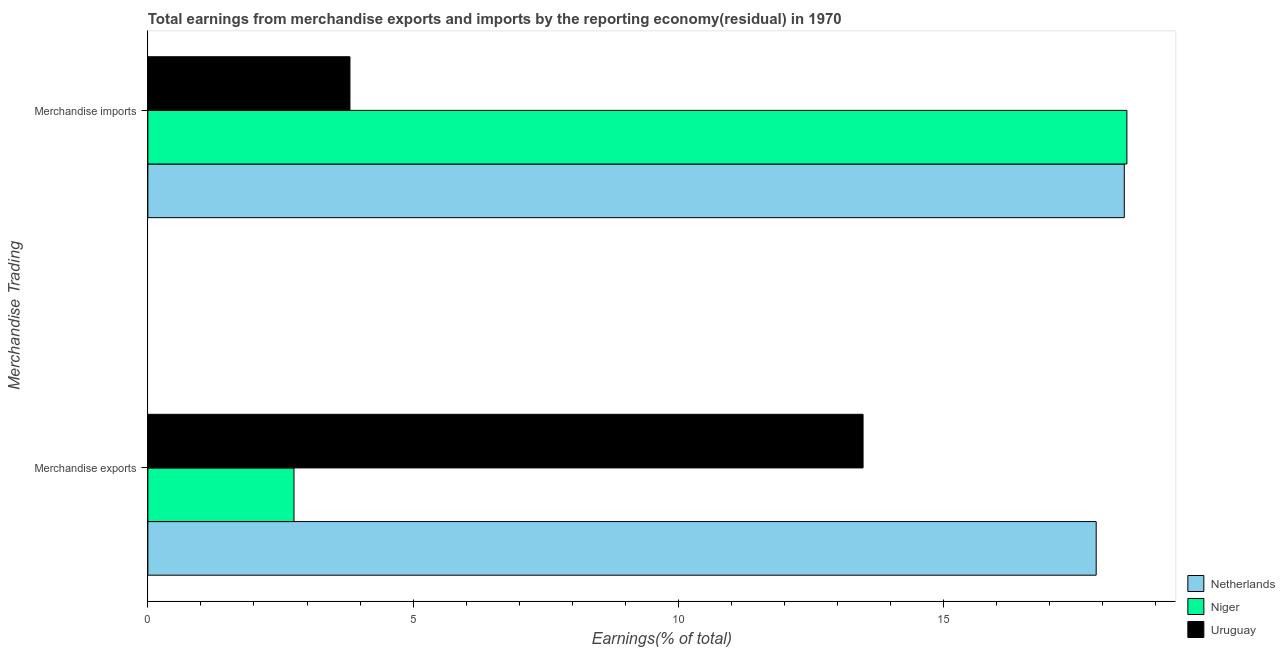Are the number of bars per tick equal to the number of legend labels?
Offer a terse response. Yes. How many bars are there on the 2nd tick from the top?
Your answer should be very brief. 3. How many bars are there on the 2nd tick from the bottom?
Give a very brief answer. 3. What is the earnings from merchandise imports in Uruguay?
Your answer should be very brief. 3.81. Across all countries, what is the maximum earnings from merchandise imports?
Give a very brief answer. 18.45. Across all countries, what is the minimum earnings from merchandise exports?
Make the answer very short. 2.75. In which country was the earnings from merchandise exports maximum?
Your answer should be compact. Netherlands. In which country was the earnings from merchandise exports minimum?
Ensure brevity in your answer.  Niger. What is the total earnings from merchandise imports in the graph?
Keep it short and to the point. 40.67. What is the difference between the earnings from merchandise imports in Uruguay and that in Niger?
Offer a terse response. -14.64. What is the difference between the earnings from merchandise exports in Niger and the earnings from merchandise imports in Uruguay?
Offer a terse response. -1.05. What is the average earnings from merchandise imports per country?
Make the answer very short. 13.56. What is the difference between the earnings from merchandise imports and earnings from merchandise exports in Netherlands?
Your answer should be very brief. 0.53. What is the ratio of the earnings from merchandise exports in Netherlands to that in Uruguay?
Give a very brief answer. 1.33. Is the earnings from merchandise exports in Netherlands less than that in Niger?
Your answer should be very brief. No. In how many countries, is the earnings from merchandise imports greater than the average earnings from merchandise imports taken over all countries?
Offer a very short reply. 2. What does the 2nd bar from the top in Merchandise exports represents?
Keep it short and to the point. Niger. What does the 1st bar from the bottom in Merchandise imports represents?
Keep it short and to the point. Netherlands. How many countries are there in the graph?
Offer a terse response. 3. What is the difference between two consecutive major ticks on the X-axis?
Offer a terse response. 5. How many legend labels are there?
Ensure brevity in your answer.  3. What is the title of the graph?
Your answer should be very brief. Total earnings from merchandise exports and imports by the reporting economy(residual) in 1970. What is the label or title of the X-axis?
Provide a short and direct response. Earnings(% of total). What is the label or title of the Y-axis?
Offer a terse response. Merchandise Trading. What is the Earnings(% of total) of Netherlands in Merchandise exports?
Your response must be concise. 17.87. What is the Earnings(% of total) in Niger in Merchandise exports?
Provide a succinct answer. 2.75. What is the Earnings(% of total) of Uruguay in Merchandise exports?
Your answer should be very brief. 13.48. What is the Earnings(% of total) in Netherlands in Merchandise imports?
Keep it short and to the point. 18.4. What is the Earnings(% of total) in Niger in Merchandise imports?
Provide a succinct answer. 18.45. What is the Earnings(% of total) of Uruguay in Merchandise imports?
Give a very brief answer. 3.81. Across all Merchandise Trading, what is the maximum Earnings(% of total) in Netherlands?
Make the answer very short. 18.4. Across all Merchandise Trading, what is the maximum Earnings(% of total) in Niger?
Your answer should be compact. 18.45. Across all Merchandise Trading, what is the maximum Earnings(% of total) of Uruguay?
Ensure brevity in your answer.  13.48. Across all Merchandise Trading, what is the minimum Earnings(% of total) in Netherlands?
Give a very brief answer. 17.87. Across all Merchandise Trading, what is the minimum Earnings(% of total) of Niger?
Provide a succinct answer. 2.75. Across all Merchandise Trading, what is the minimum Earnings(% of total) in Uruguay?
Offer a terse response. 3.81. What is the total Earnings(% of total) in Netherlands in the graph?
Give a very brief answer. 36.28. What is the total Earnings(% of total) of Niger in the graph?
Provide a short and direct response. 21.21. What is the total Earnings(% of total) of Uruguay in the graph?
Make the answer very short. 17.29. What is the difference between the Earnings(% of total) of Netherlands in Merchandise exports and that in Merchandise imports?
Provide a short and direct response. -0.53. What is the difference between the Earnings(% of total) in Niger in Merchandise exports and that in Merchandise imports?
Your response must be concise. -15.7. What is the difference between the Earnings(% of total) of Uruguay in Merchandise exports and that in Merchandise imports?
Ensure brevity in your answer.  9.67. What is the difference between the Earnings(% of total) in Netherlands in Merchandise exports and the Earnings(% of total) in Niger in Merchandise imports?
Your answer should be compact. -0.58. What is the difference between the Earnings(% of total) in Netherlands in Merchandise exports and the Earnings(% of total) in Uruguay in Merchandise imports?
Give a very brief answer. 14.06. What is the difference between the Earnings(% of total) of Niger in Merchandise exports and the Earnings(% of total) of Uruguay in Merchandise imports?
Keep it short and to the point. -1.05. What is the average Earnings(% of total) in Netherlands per Merchandise Trading?
Provide a succinct answer. 18.14. What is the average Earnings(% of total) of Niger per Merchandise Trading?
Offer a very short reply. 10.6. What is the average Earnings(% of total) of Uruguay per Merchandise Trading?
Your answer should be compact. 8.64. What is the difference between the Earnings(% of total) of Netherlands and Earnings(% of total) of Niger in Merchandise exports?
Provide a succinct answer. 15.12. What is the difference between the Earnings(% of total) of Netherlands and Earnings(% of total) of Uruguay in Merchandise exports?
Provide a succinct answer. 4.39. What is the difference between the Earnings(% of total) of Niger and Earnings(% of total) of Uruguay in Merchandise exports?
Provide a succinct answer. -10.73. What is the difference between the Earnings(% of total) in Netherlands and Earnings(% of total) in Niger in Merchandise imports?
Provide a short and direct response. -0.05. What is the difference between the Earnings(% of total) in Netherlands and Earnings(% of total) in Uruguay in Merchandise imports?
Keep it short and to the point. 14.59. What is the difference between the Earnings(% of total) in Niger and Earnings(% of total) in Uruguay in Merchandise imports?
Your response must be concise. 14.64. What is the ratio of the Earnings(% of total) in Netherlands in Merchandise exports to that in Merchandise imports?
Your answer should be very brief. 0.97. What is the ratio of the Earnings(% of total) of Niger in Merchandise exports to that in Merchandise imports?
Keep it short and to the point. 0.15. What is the ratio of the Earnings(% of total) in Uruguay in Merchandise exports to that in Merchandise imports?
Your answer should be compact. 3.54. What is the difference between the highest and the second highest Earnings(% of total) of Netherlands?
Your answer should be compact. 0.53. What is the difference between the highest and the second highest Earnings(% of total) of Niger?
Your answer should be very brief. 15.7. What is the difference between the highest and the second highest Earnings(% of total) of Uruguay?
Keep it short and to the point. 9.67. What is the difference between the highest and the lowest Earnings(% of total) in Netherlands?
Keep it short and to the point. 0.53. What is the difference between the highest and the lowest Earnings(% of total) in Niger?
Provide a short and direct response. 15.7. What is the difference between the highest and the lowest Earnings(% of total) in Uruguay?
Your answer should be compact. 9.67. 